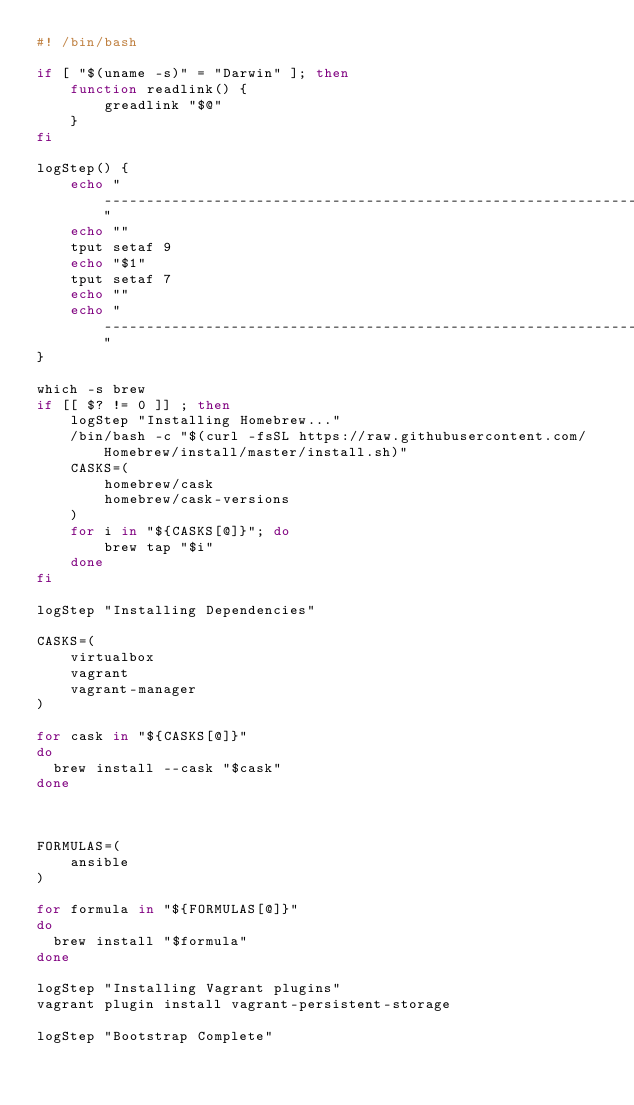<code> <loc_0><loc_0><loc_500><loc_500><_Bash_>#! /bin/bash

if [ "$(uname -s)" = "Darwin" ]; then
    function readlink() {
        greadlink "$@"
    }
fi

logStep() {
    echo "-------------------------------------------------------------------"
    echo ""
    tput setaf 9
    echo "$1"
    tput setaf 7
    echo ""
    echo "-------------------------------------------------------------------"
}

which -s brew
if [[ $? != 0 ]] ; then
    logStep "Installing Homebrew..."
    /bin/bash -c "$(curl -fsSL https://raw.githubusercontent.com/Homebrew/install/master/install.sh)"
    CASKS=(
        homebrew/cask
        homebrew/cask-versions
    )
    for i in "${CASKS[@]}"; do
        brew tap "$i"
    done
fi

logStep "Installing Dependencies"

CASKS=(
    virtualbox
    vagrant
    vagrant-manager
)

for cask in "${CASKS[@]}"
do
  brew install --cask "$cask"
done



FORMULAS=(
    ansible
)

for formula in "${FORMULAS[@]}"
do
  brew install "$formula"
done

logStep "Installing Vagrant plugins"
vagrant plugin install vagrant-persistent-storage

logStep "Bootstrap Complete"
</code> 